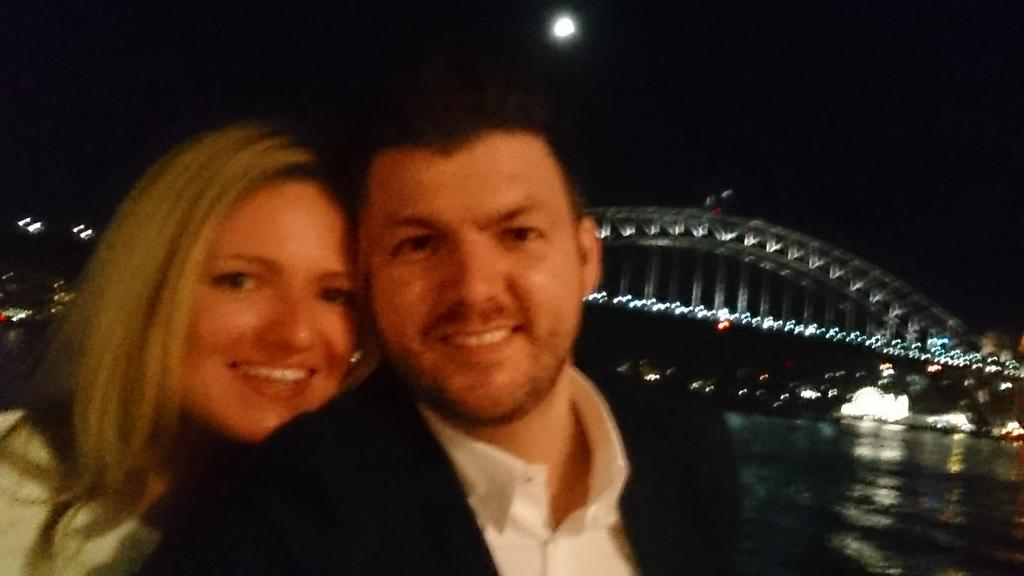How many people are present in the image? There is a man and a woman in the image. What is the lighting situation in the image? There are lights visible in the image. What type of natural element can be seen in the image? There is water visible in the image. What type of structure is present in the image? There is a bridge in the image. Can you tell me how many cattle are crossing the bridge in the image? There are no cattle present in the image; it features a man, a woman, and a bridge. What type of beggar can be seen in the image? There is no beggar present in the image. 